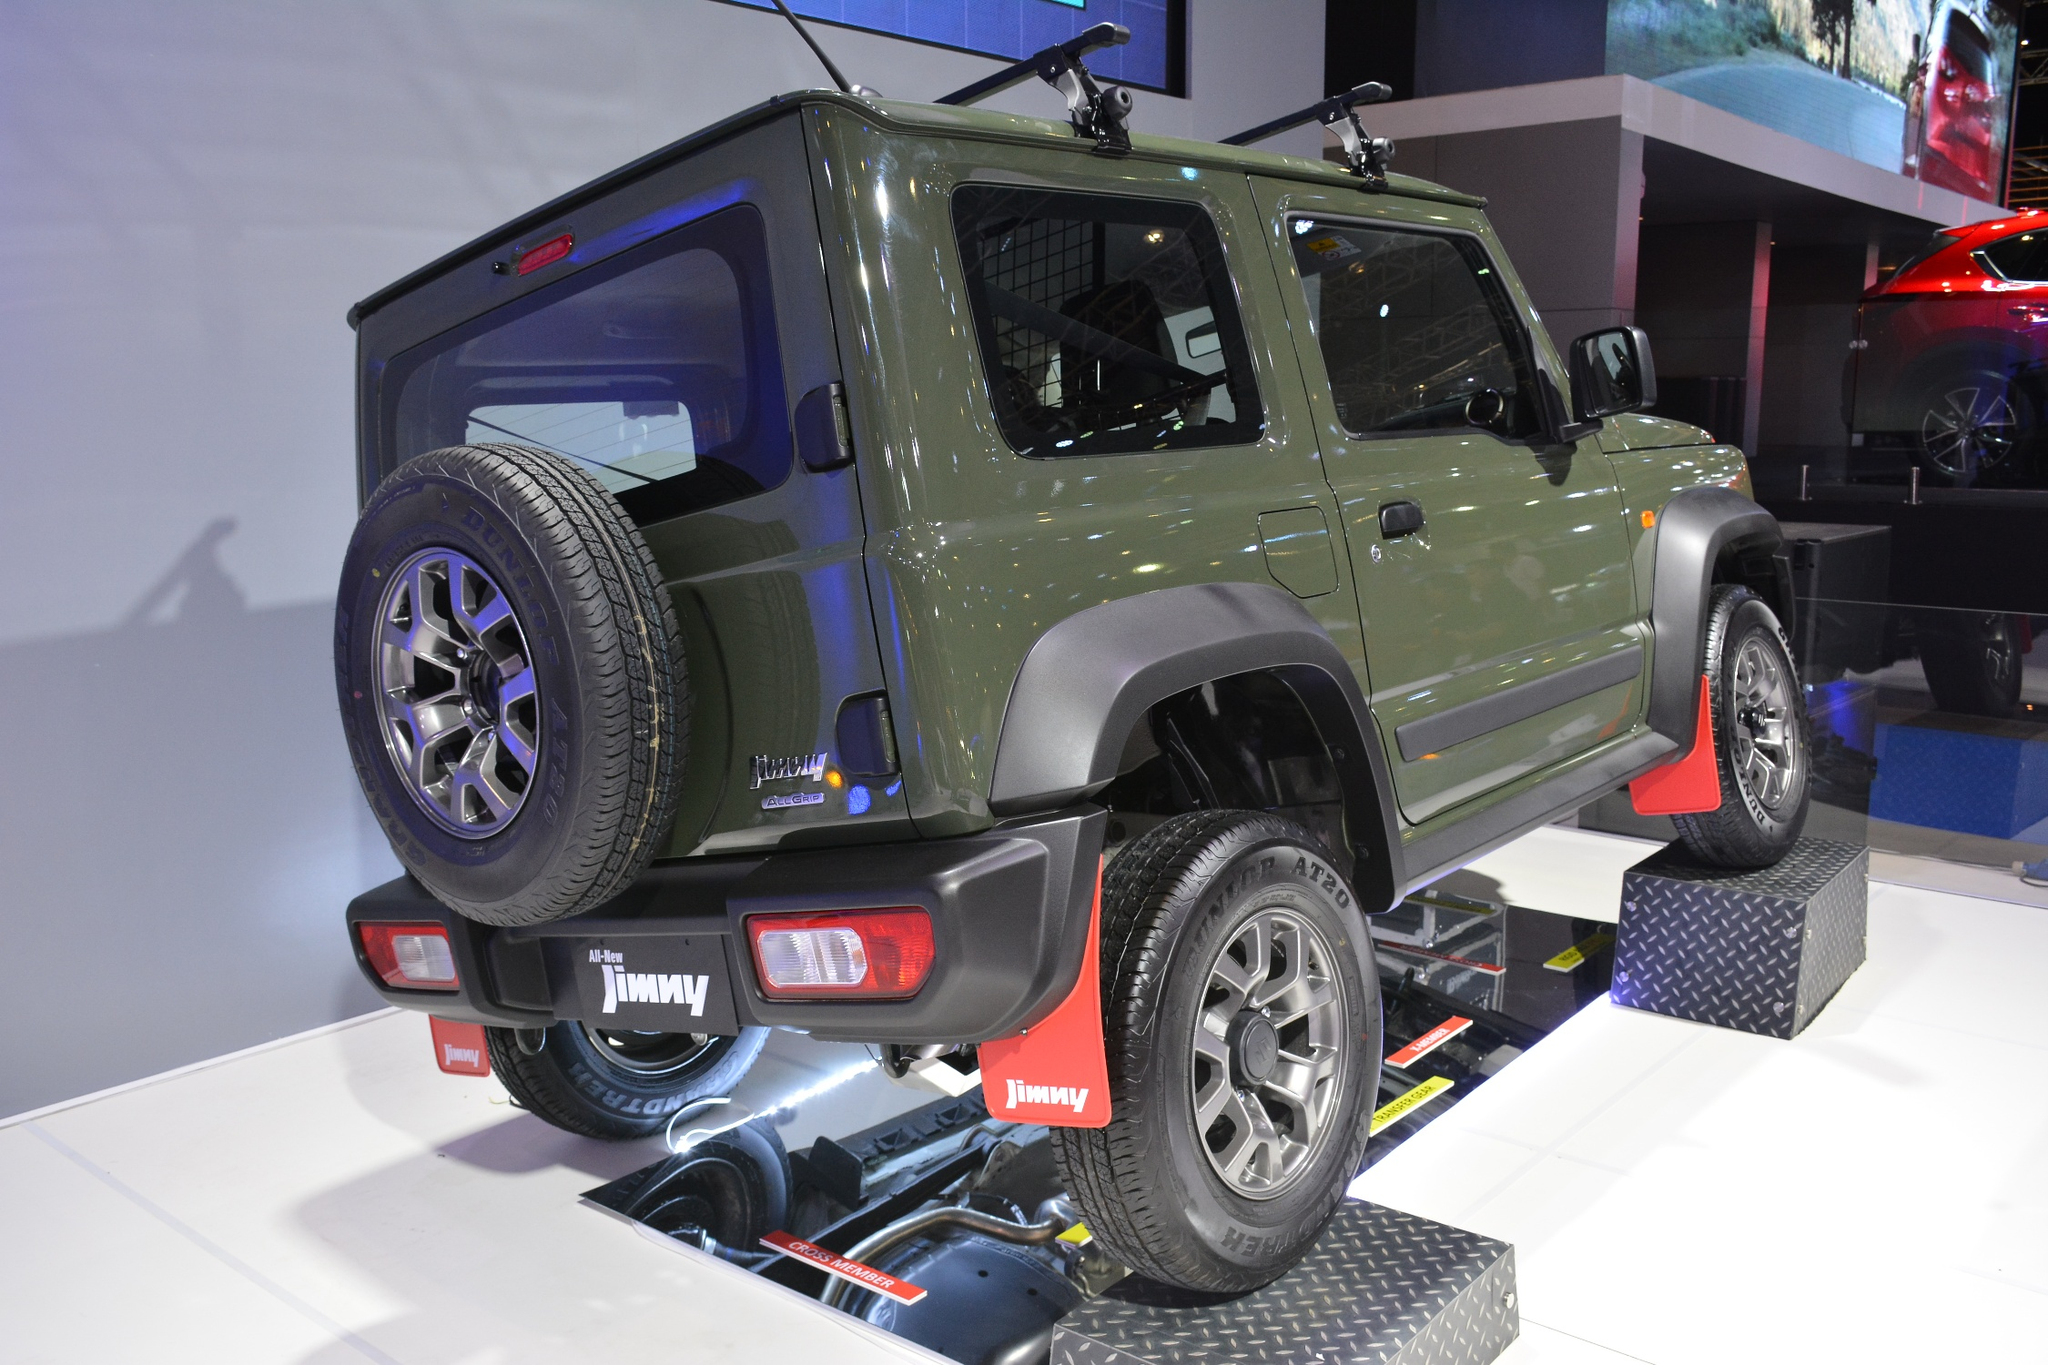Could you tell me a short advertising tagline for this Suzuki Jimny? Sure! How about this: 'Suzuki Jimny - Unleash Your Adventure!' 